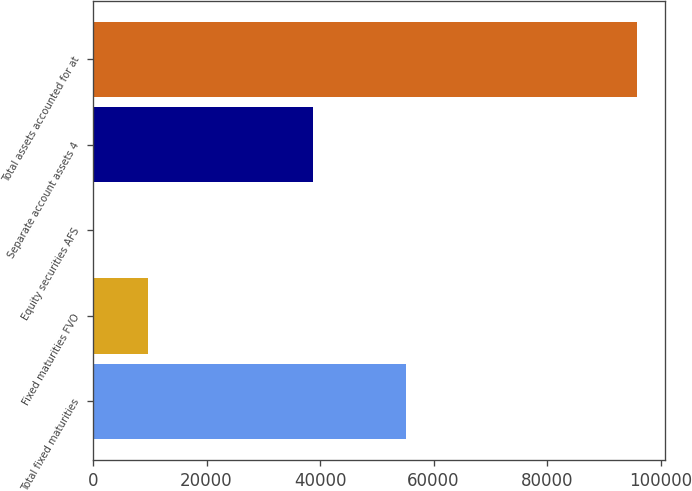<chart> <loc_0><loc_0><loc_500><loc_500><bar_chart><fcel>Total fixed maturities<fcel>Fixed maturities FVO<fcel>Equity securities AFS<fcel>Separate account assets 4<fcel>Total assets accounted for at<nl><fcel>55143<fcel>9729.3<fcel>154<fcel>38700<fcel>95907<nl></chart> 